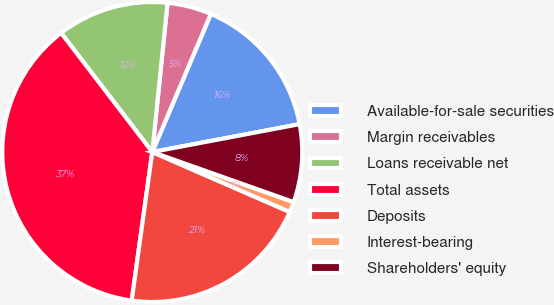<chart> <loc_0><loc_0><loc_500><loc_500><pie_chart><fcel>Available-for-sale securities<fcel>Margin receivables<fcel>Loans receivable net<fcel>Total assets<fcel>Deposits<fcel>Interest-bearing<fcel>Shareholders' equity<nl><fcel>15.64%<fcel>4.76%<fcel>12.02%<fcel>37.41%<fcel>20.65%<fcel>1.13%<fcel>8.39%<nl></chart> 